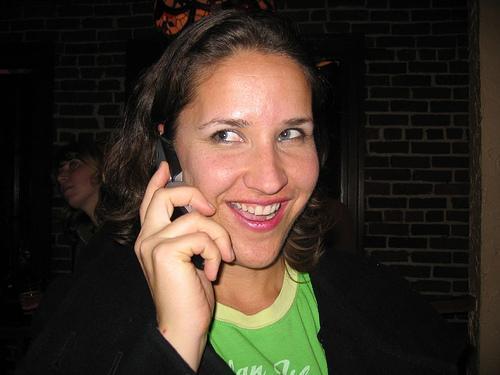How many people are in the picture?
Give a very brief answer. 1. How many fingers do you see?
Give a very brief answer. 4. How many people are there?
Give a very brief answer. 2. How many window panels are on each bus door?
Give a very brief answer. 0. 